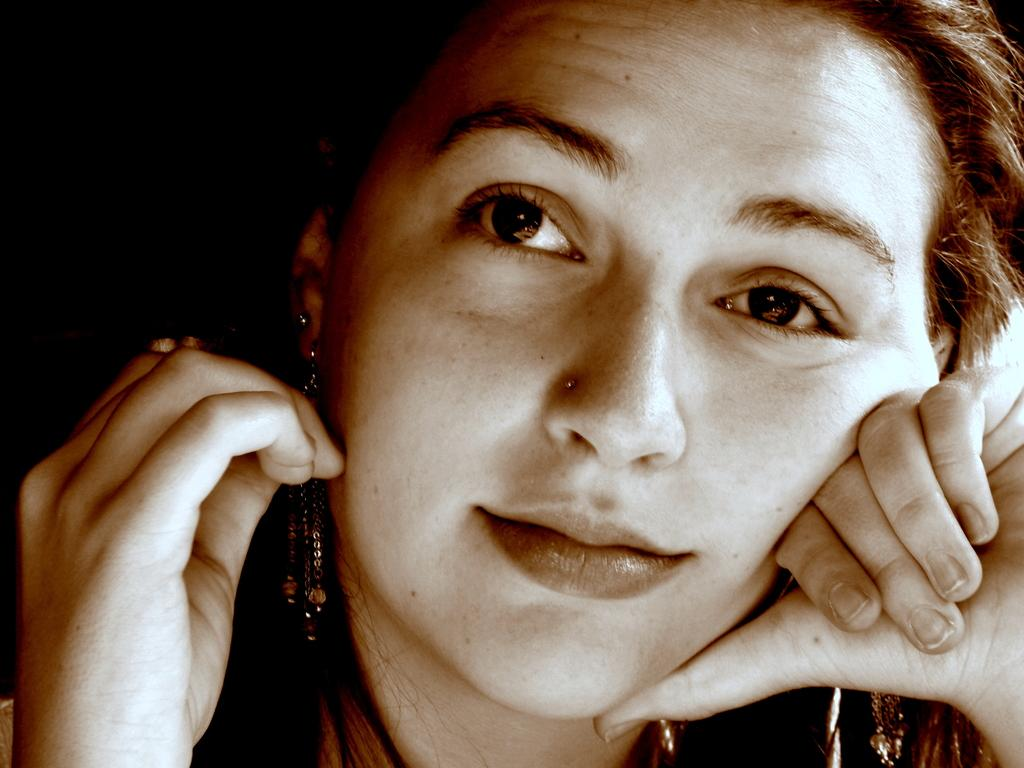Who is present in the image? There is a woman in the image. Can you describe any specific details about the woman? Unfortunately, the provided facts do not mention any specific details about the woman. What is the condition of the top left corner of the image? The top left corner of the image is dark. How many clams are visible on the woman's tongue in the image? There are no clams or tongues visible in the image; it only features a woman and a dark top left corner. 